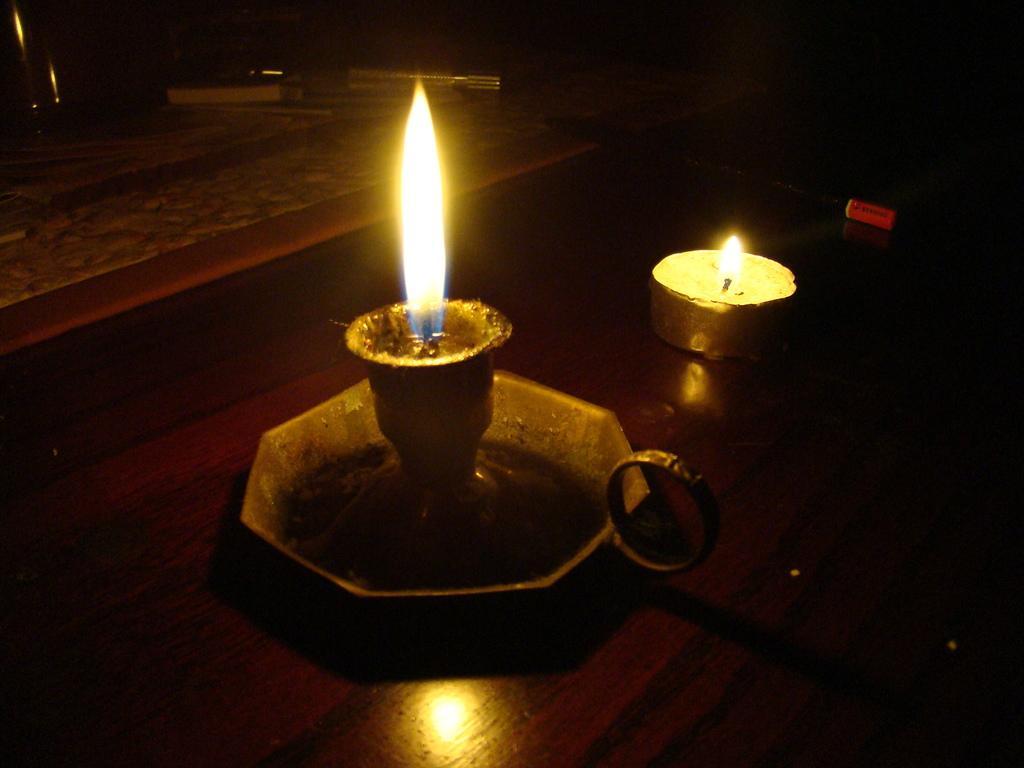Could you give a brief overview of what you see in this image? In this image we can see two candles on the surface, also we can see some other objects around them. 